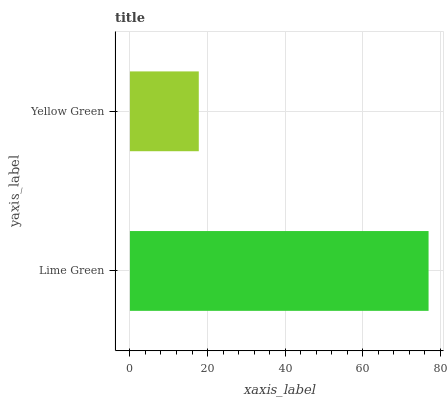Is Yellow Green the minimum?
Answer yes or no. Yes. Is Lime Green the maximum?
Answer yes or no. Yes. Is Yellow Green the maximum?
Answer yes or no. No. Is Lime Green greater than Yellow Green?
Answer yes or no. Yes. Is Yellow Green less than Lime Green?
Answer yes or no. Yes. Is Yellow Green greater than Lime Green?
Answer yes or no. No. Is Lime Green less than Yellow Green?
Answer yes or no. No. Is Lime Green the high median?
Answer yes or no. Yes. Is Yellow Green the low median?
Answer yes or no. Yes. Is Yellow Green the high median?
Answer yes or no. No. Is Lime Green the low median?
Answer yes or no. No. 